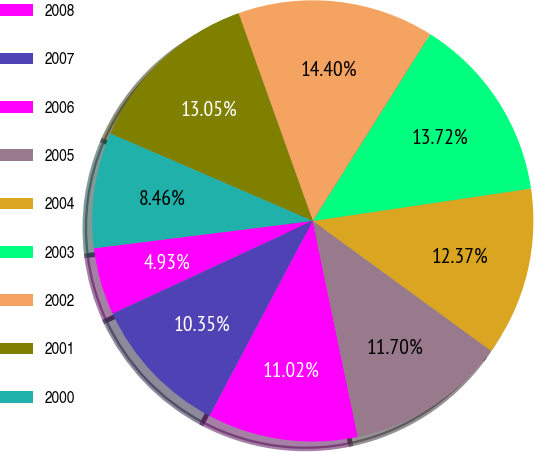<chart> <loc_0><loc_0><loc_500><loc_500><pie_chart><fcel>2008<fcel>2007<fcel>2006<fcel>2005<fcel>2004<fcel>2003<fcel>2002<fcel>2001<fcel>2000<nl><fcel>4.93%<fcel>10.35%<fcel>11.02%<fcel>11.7%<fcel>12.37%<fcel>13.72%<fcel>14.4%<fcel>13.05%<fcel>8.46%<nl></chart> 